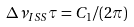Convert formula to latex. <formula><loc_0><loc_0><loc_500><loc_500>\Delta \nu _ { I S S } \tau = C _ { 1 } / ( 2 \pi )</formula> 